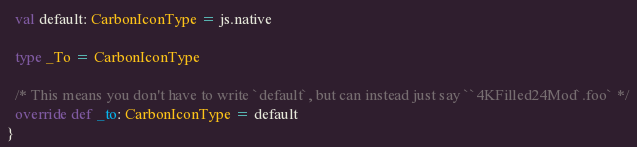Convert code to text. <code><loc_0><loc_0><loc_500><loc_500><_Scala_>  val default: CarbonIconType = js.native
  
  type _To = CarbonIconType
  
  /* This means you don't have to write `default`, but can instead just say ``4KFilled24Mod`.foo` */
  override def _to: CarbonIconType = default
}
</code> 